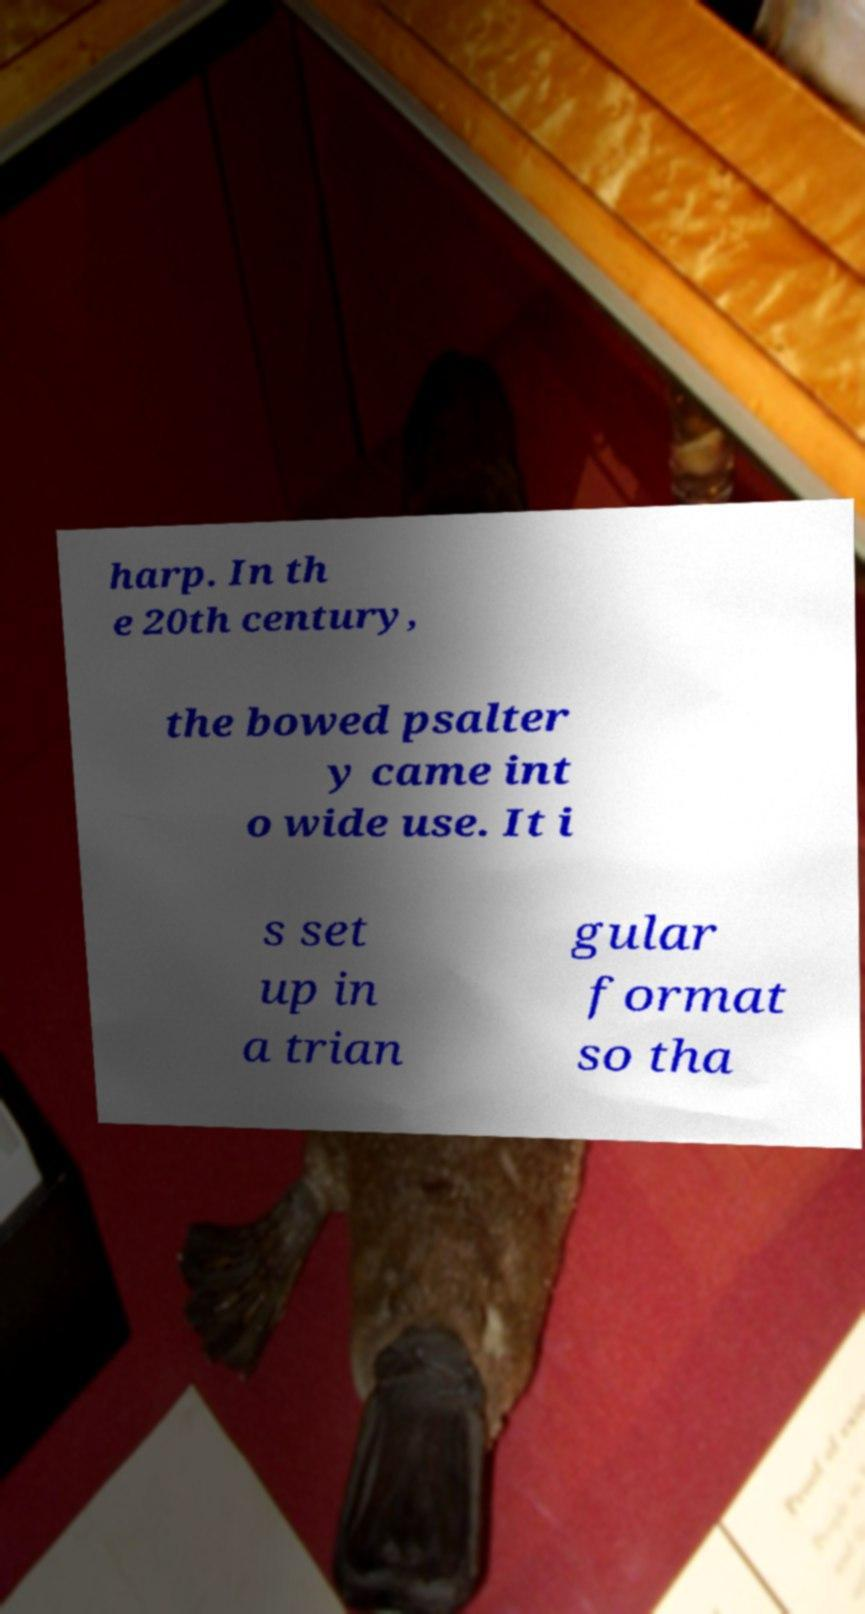Please identify and transcribe the text found in this image. harp. In th e 20th century, the bowed psalter y came int o wide use. It i s set up in a trian gular format so tha 